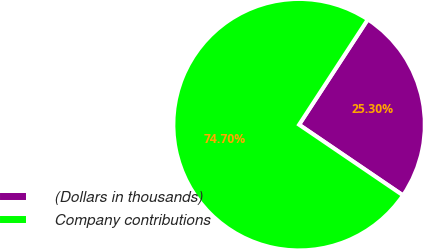Convert chart to OTSL. <chart><loc_0><loc_0><loc_500><loc_500><pie_chart><fcel>(Dollars in thousands)<fcel>Company contributions<nl><fcel>25.3%<fcel>74.7%<nl></chart> 